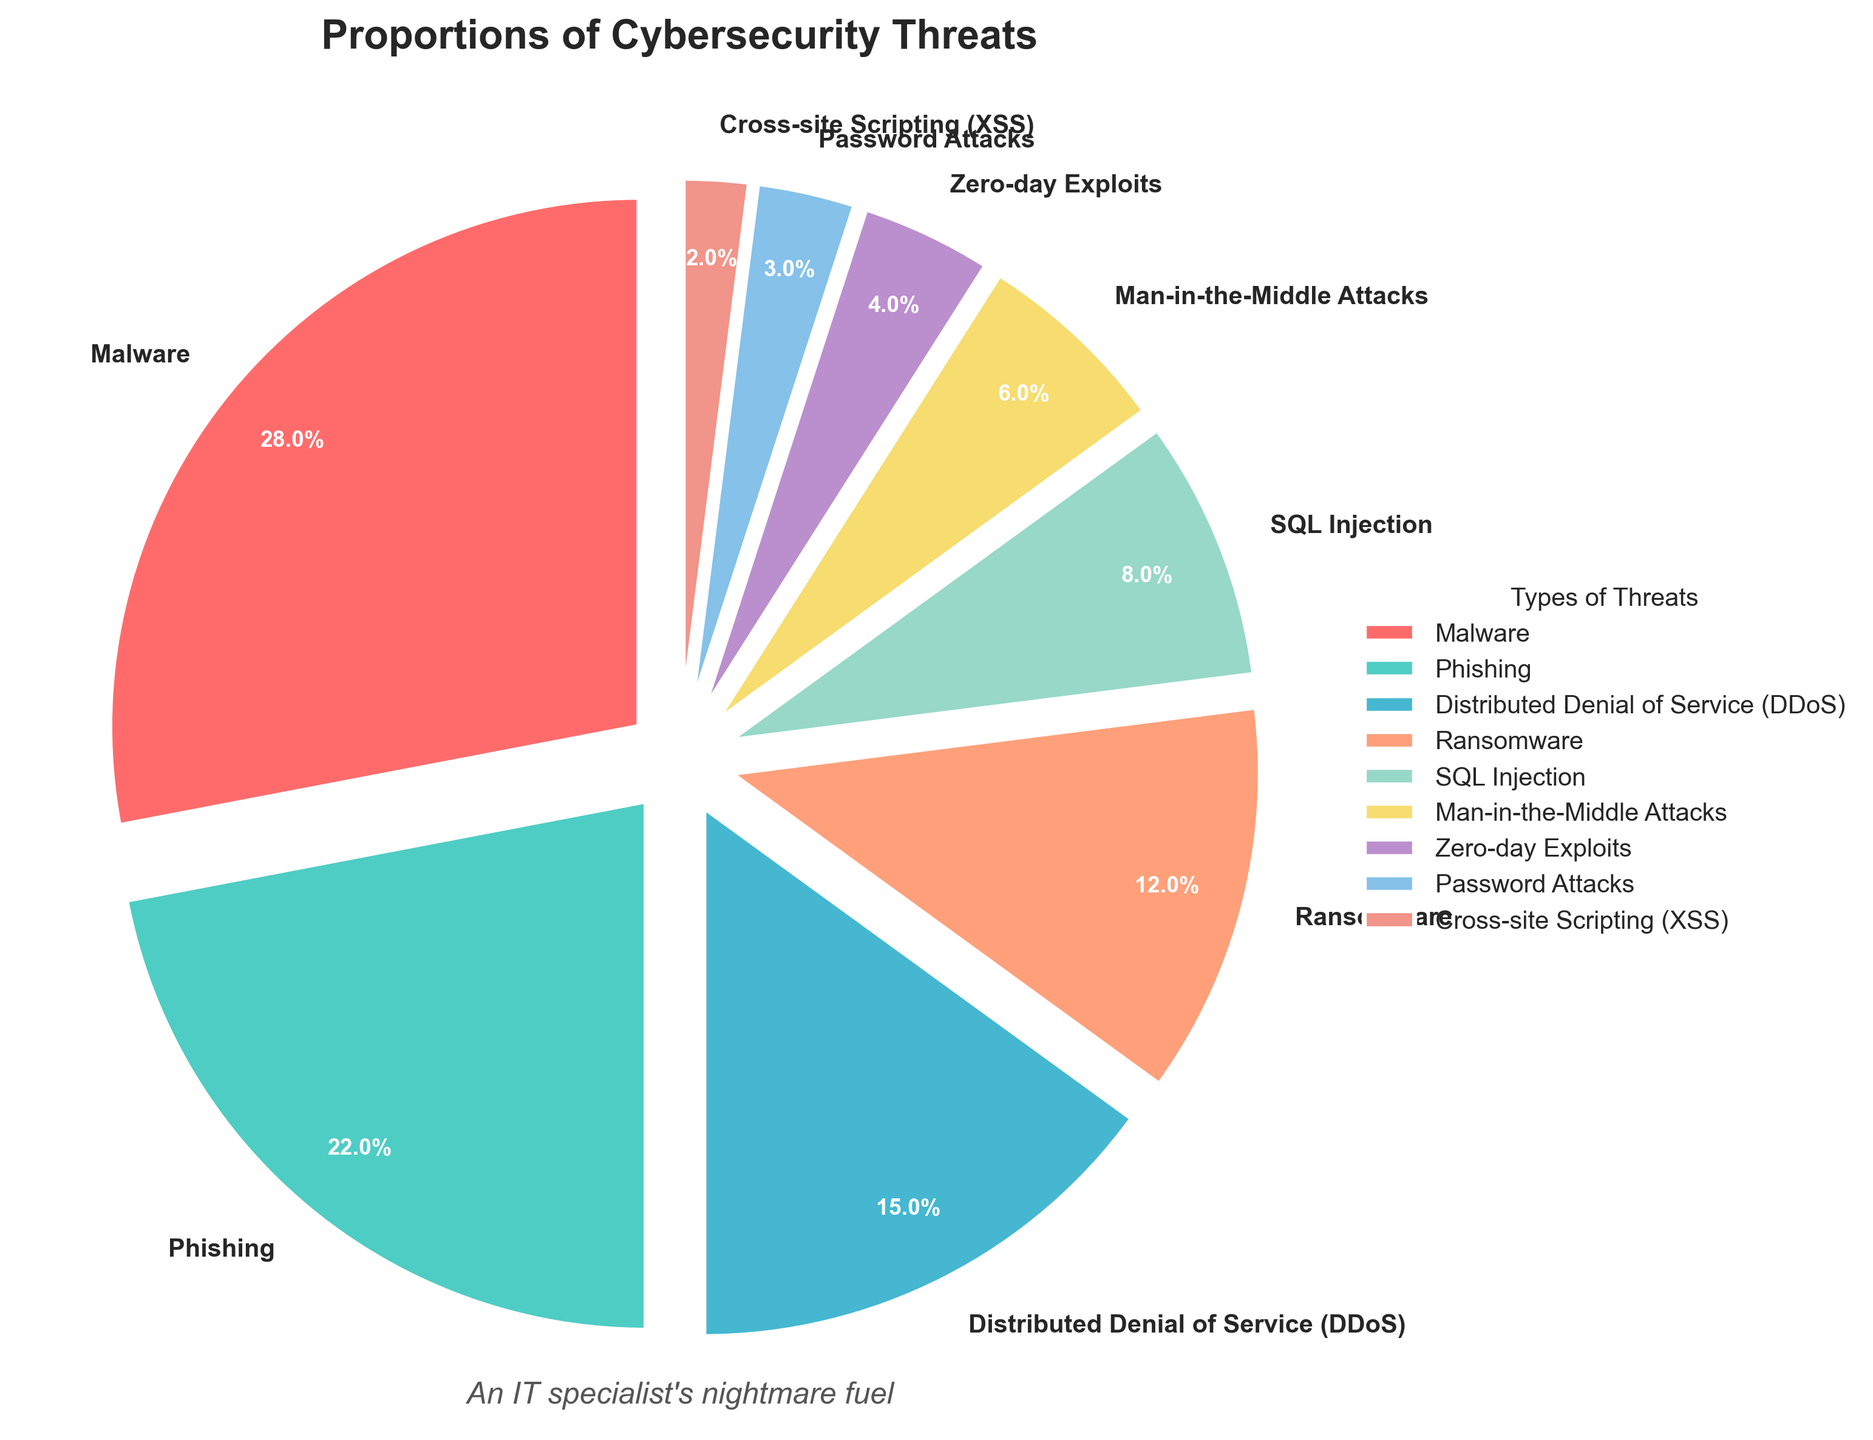Which type of cybersecurity threat is the most prevalent based on the figure? By looking at the largest segment, we can see that "Malware" occupies the biggest portion of the pie chart, indicating it is the most prevalent threat.
Answer: Malware What is the combined percentage of Phishing and Ransomware threats? According to the figure, Phishing is 22% and Ransomware is 12%. Adding these together gives us 22 + 12 = 34%.
Answer: 34% How does the proportion of SQL Injection compare to that of Man-in-the-Middle Attacks? The pie chart shows that SQL Injection has a percentage of 8%, while Man-in-the-Middle Attacks have a percentage of 6%. Therefore, SQL Injection is more prevalent than Man-in-the-Middle Attacks.
Answer: SQL Injection is more prevalent Which segment is the smallest, and what is its percentage? Observing the smallest segment in the pie chart, it is the segment for Cross-site Scripting (XSS) which is 2%.
Answer: Cross-site Scripting (XSS), 2% What is the total percentage of threats related to Malware, Phishing, and Distributed Denial of Service (DDoS)? From the pie chart: Malware is 28%, Phishing is 22%, and Distributed Denial of Service (DDoS) is 15%. Summing these gives us 28 + 22 + 15 = 65%.
Answer: 65% How many threats have a percentage of less than 5% each? From the figure, the threats below 5% are Zero-day Exploits (4%), Password Attacks (3%), and Cross-site Scripting (2%), totaling three threats.
Answer: 3 What percentage of the chart do Man-in-the-Middle Attacks and Zero-day Exploits together account for? According to the figure, Man-in-the-Middle Attacks account for 6% and Zero-day Exploits account for 4%. Together, they make up 6 + 4 = 10%.
Answer: 10% What is the difference in percentage between the largest and second-largest threat categories? From the pie chart, the largest threat is Malware at 28% and the second largest is Phishing at 22%. The difference is 28 - 22 = 6%.
Answer: 6% Which threat is represented by the green segment in the pie chart and what percentage does it represent? By looking at the legend and corresponding colors in the pie chart, the green segment represents Phishing which is 22%.
Answer: Phishing, 22% Is the percentage of Password Attacks greater than one-third of the percentage of Ransomware attacks? According to the figure, Password Attacks are 3% and Ransomware is 12%. One-third of 12% is 12/3 = 4%. Since 3% is less than 4%, the percentage of Password Attacks is not greater than one-third of Ransomware attacks.
Answer: No 